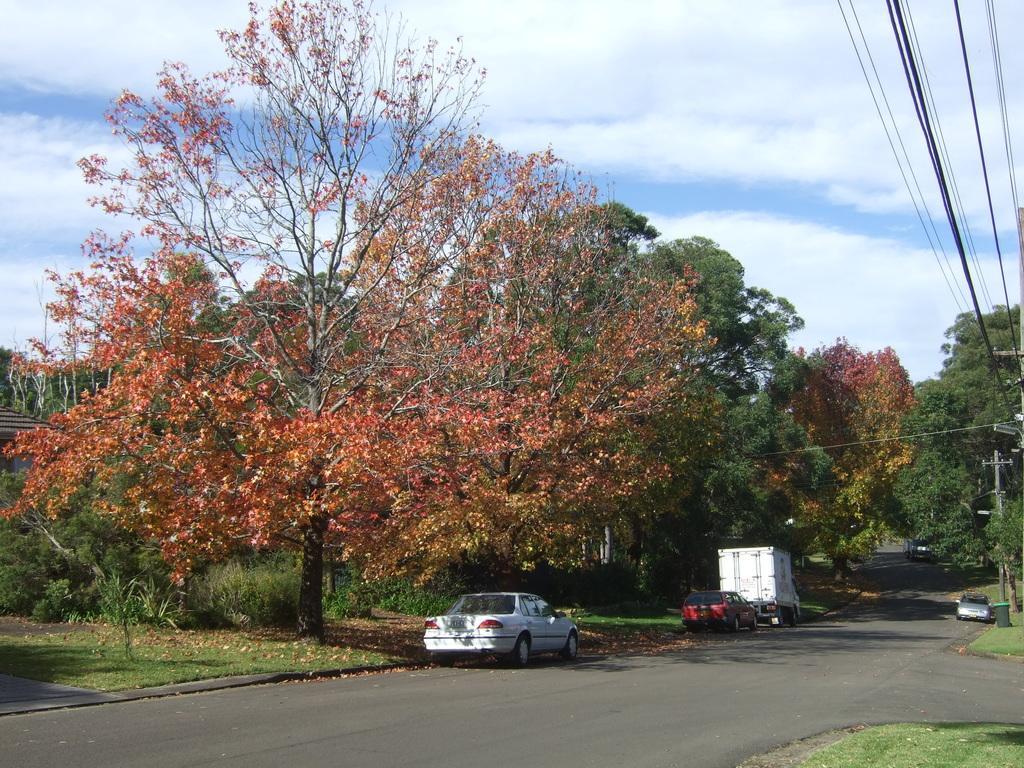Could you give a brief overview of what you see in this image? In this image we can see a road and some vehicles are parked on road. To the left side of the road so many trees are present. To the right side of the image one pole is there and electric wires are attached to the pole. 